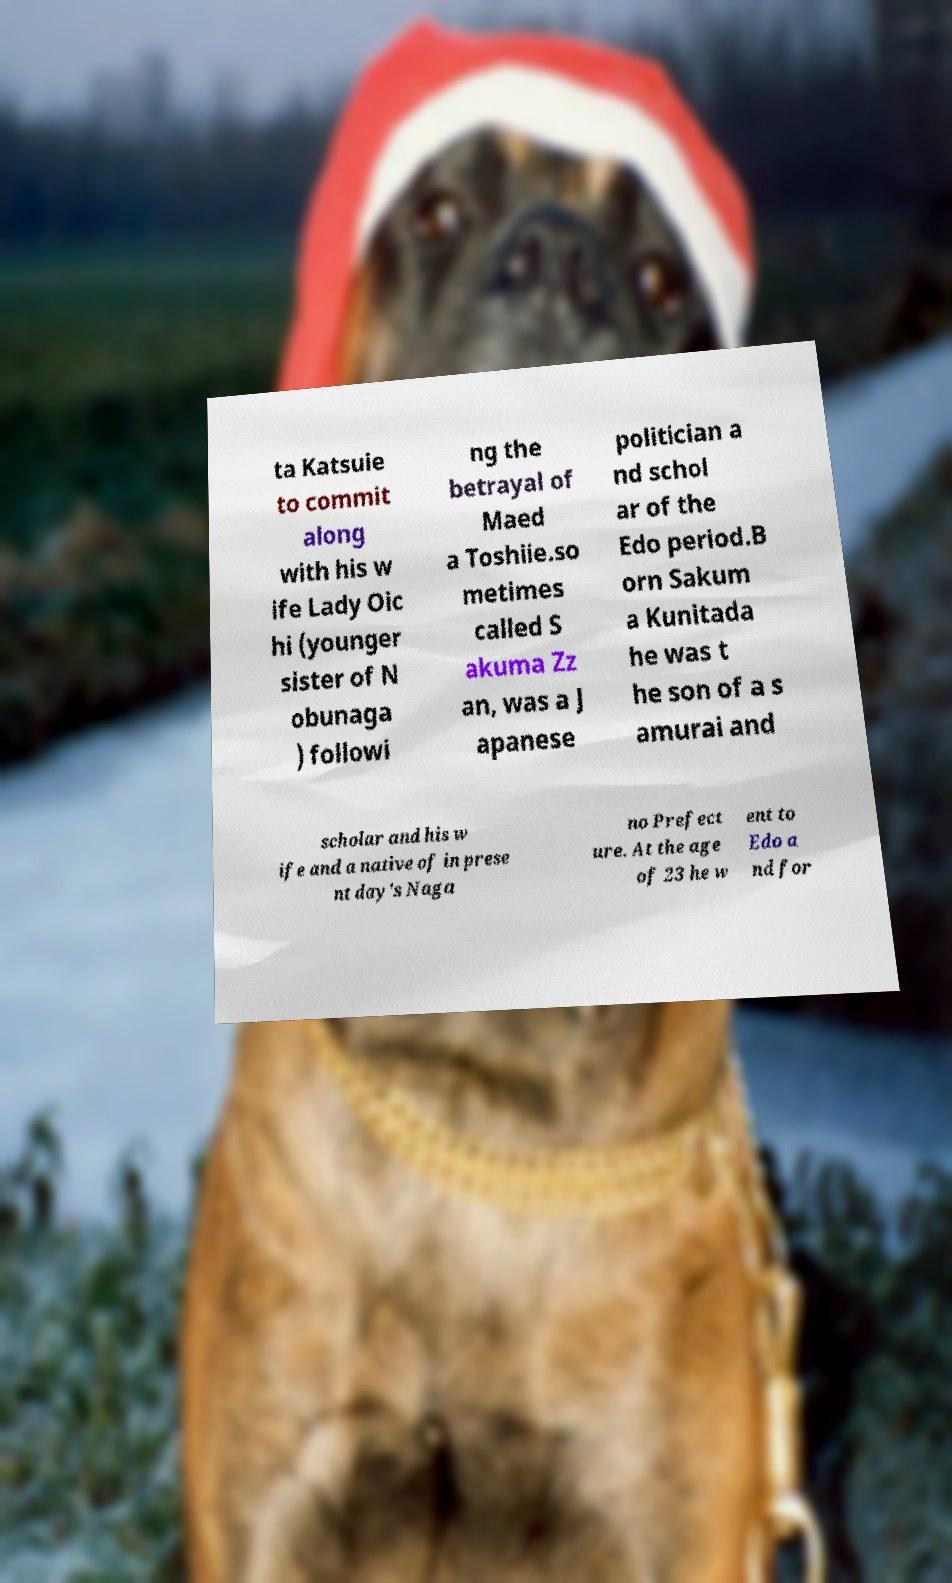What messages or text are displayed in this image? I need them in a readable, typed format. ta Katsuie to commit along with his w ife Lady Oic hi (younger sister of N obunaga ) followi ng the betrayal of Maed a Toshiie.so metimes called S akuma Zz an, was a J apanese politician a nd schol ar of the Edo period.B orn Sakum a Kunitada he was t he son of a s amurai and scholar and his w ife and a native of in prese nt day's Naga no Prefect ure. At the age of 23 he w ent to Edo a nd for 